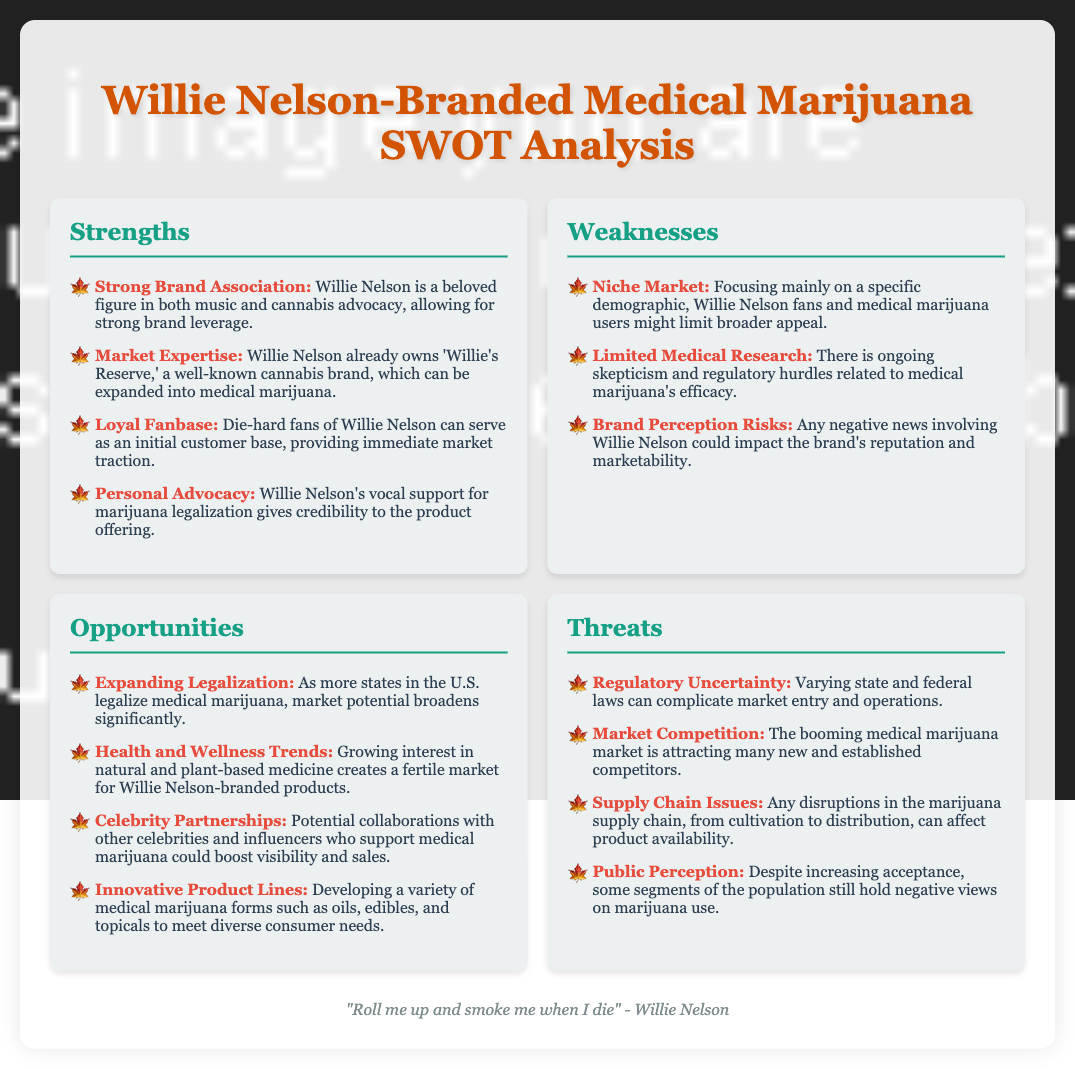What is the first strength listed in the SWOT analysis? The first strength mentioned is "Strong Brand Association," indicating Willie Nelson's appeal in music and cannabis advocacy.
Answer: Strong Brand Association What are the opportunities listed in the SWOT analysis? The opportunities include "Expanding Legalization," "Health and Wellness Trends," "Celebrity Partnerships," and "Innovative Product Lines."
Answer: Expanding Legalization, Health and Wellness Trends, Celebrity Partnerships, Innovative Product Lines What weakness relates to market scope? The weakness mentioned is "Niche Market," which highlights a focus on a specific demographic, potentially limiting appeal.
Answer: Niche Market How many threats are identified in the SWOT analysis? The document lists four threats under the Threats section, addressing various concerns.
Answer: Four Which celebrity brand is mentioned as already being owned by Willie Nelson? The brand specifically referenced in the document is "Willie's Reserve," known in the cannabis market.
Answer: Willie's Reserve What does the document suggest can complicate market entry? The section on threats highlights "Regulatory Uncertainty" as a factor complicating market entry and operations.
Answer: Regulatory Uncertainty What negative view could affect Willie Nelson-branded products despite increasing acceptance? The document states that "Public Perception" may still hold negative views on marijuana use.
Answer: Public Perception What is the likely consumer demographic targeted by Willie Nelson-branded medical marijuana products? The target demographic identified is primarily "Willie Nelson fans and medical marijuana users."
Answer: Willie Nelson fans and medical marijuana users How does Willie Nelson's advocacy contribute to his brand? His "Personal Advocacy" for marijuana legalization adds credibility to the product offerings in the market.
Answer: Personal Advocacy 